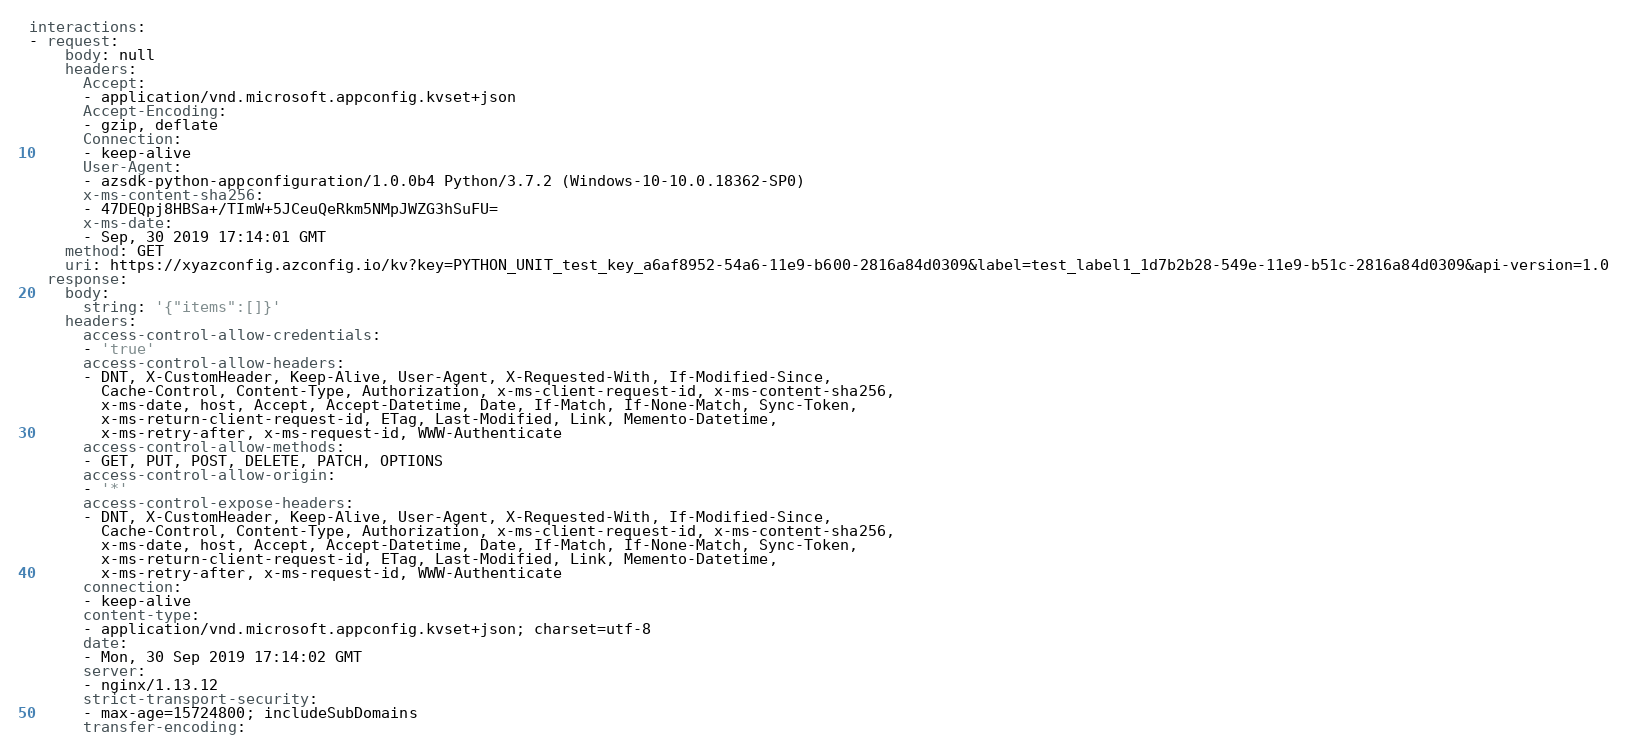Convert code to text. <code><loc_0><loc_0><loc_500><loc_500><_YAML_>interactions:
- request:
    body: null
    headers:
      Accept:
      - application/vnd.microsoft.appconfig.kvset+json
      Accept-Encoding:
      - gzip, deflate
      Connection:
      - keep-alive
      User-Agent:
      - azsdk-python-appconfiguration/1.0.0b4 Python/3.7.2 (Windows-10-10.0.18362-SP0)
      x-ms-content-sha256:
      - 47DEQpj8HBSa+/TImW+5JCeuQeRkm5NMpJWZG3hSuFU=
      x-ms-date:
      - Sep, 30 2019 17:14:01 GMT
    method: GET
    uri: https://xyazconfig.azconfig.io/kv?key=PYTHON_UNIT_test_key_a6af8952-54a6-11e9-b600-2816a84d0309&label=test_label1_1d7b2b28-549e-11e9-b51c-2816a84d0309&api-version=1.0
  response:
    body:
      string: '{"items":[]}'
    headers:
      access-control-allow-credentials:
      - 'true'
      access-control-allow-headers:
      - DNT, X-CustomHeader, Keep-Alive, User-Agent, X-Requested-With, If-Modified-Since,
        Cache-Control, Content-Type, Authorization, x-ms-client-request-id, x-ms-content-sha256,
        x-ms-date, host, Accept, Accept-Datetime, Date, If-Match, If-None-Match, Sync-Token,
        x-ms-return-client-request-id, ETag, Last-Modified, Link, Memento-Datetime,
        x-ms-retry-after, x-ms-request-id, WWW-Authenticate
      access-control-allow-methods:
      - GET, PUT, POST, DELETE, PATCH, OPTIONS
      access-control-allow-origin:
      - '*'
      access-control-expose-headers:
      - DNT, X-CustomHeader, Keep-Alive, User-Agent, X-Requested-With, If-Modified-Since,
        Cache-Control, Content-Type, Authorization, x-ms-client-request-id, x-ms-content-sha256,
        x-ms-date, host, Accept, Accept-Datetime, Date, If-Match, If-None-Match, Sync-Token,
        x-ms-return-client-request-id, ETag, Last-Modified, Link, Memento-Datetime,
        x-ms-retry-after, x-ms-request-id, WWW-Authenticate
      connection:
      - keep-alive
      content-type:
      - application/vnd.microsoft.appconfig.kvset+json; charset=utf-8
      date:
      - Mon, 30 Sep 2019 17:14:02 GMT
      server:
      - nginx/1.13.12
      strict-transport-security:
      - max-age=15724800; includeSubDomains
      transfer-encoding:</code> 